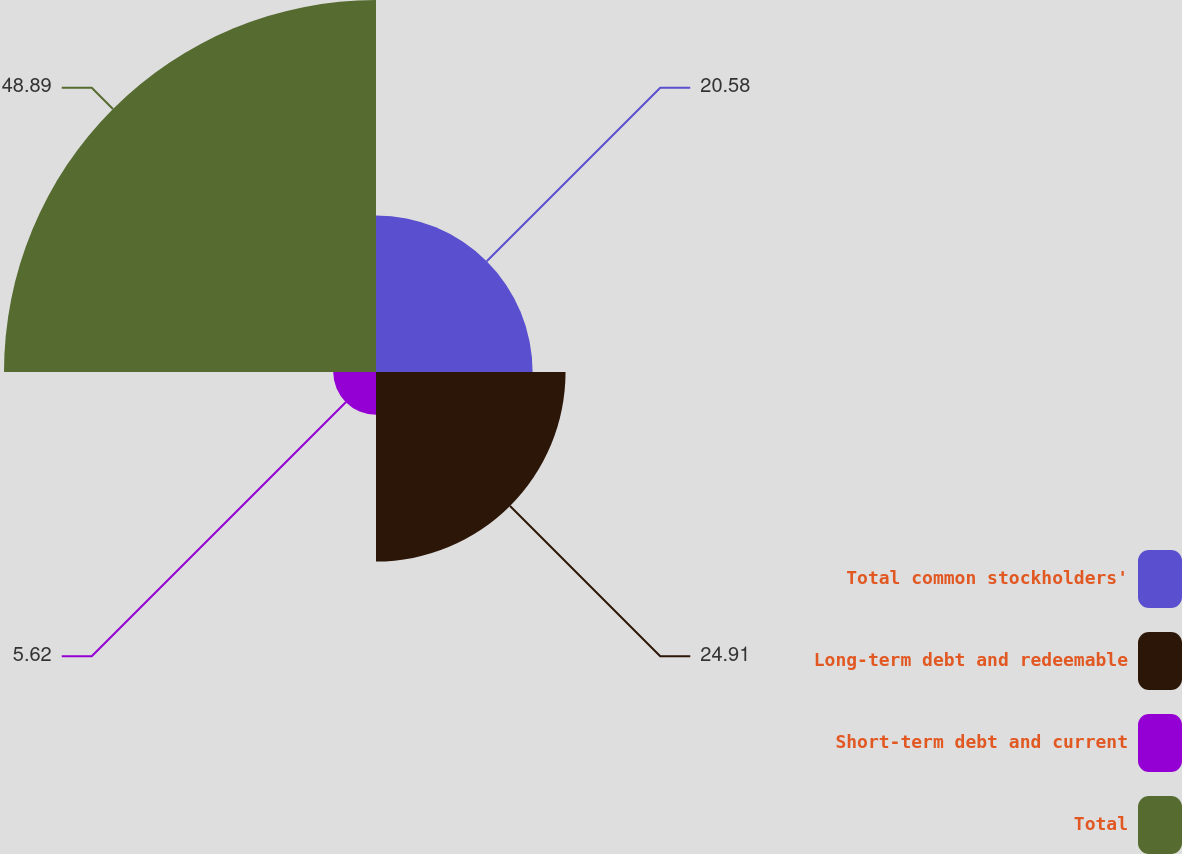Convert chart to OTSL. <chart><loc_0><loc_0><loc_500><loc_500><pie_chart><fcel>Total common stockholders'<fcel>Long-term debt and redeemable<fcel>Short-term debt and current<fcel>Total<nl><fcel>20.58%<fcel>24.91%<fcel>5.62%<fcel>48.89%<nl></chart> 